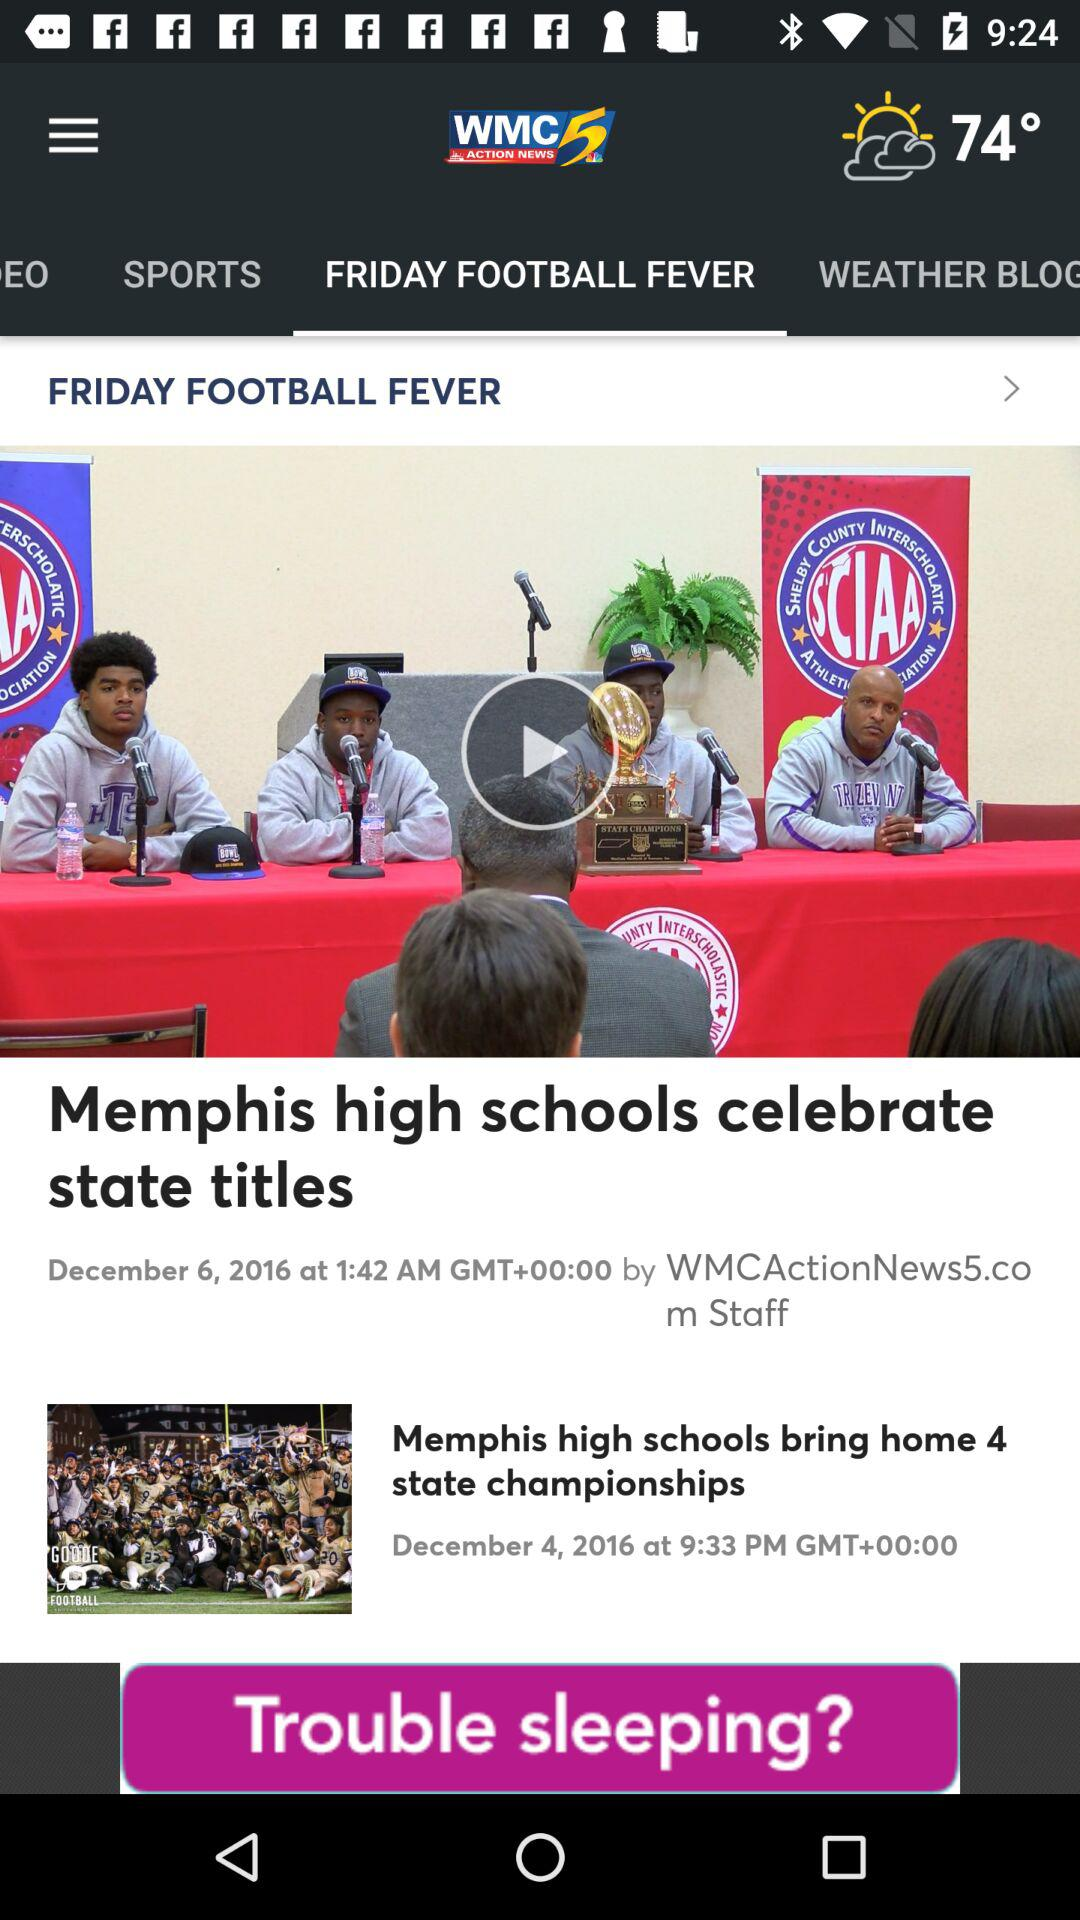When was the news "Memphis high schools celebrate state titles" uploaded? The news was published on December 6, 2016. 